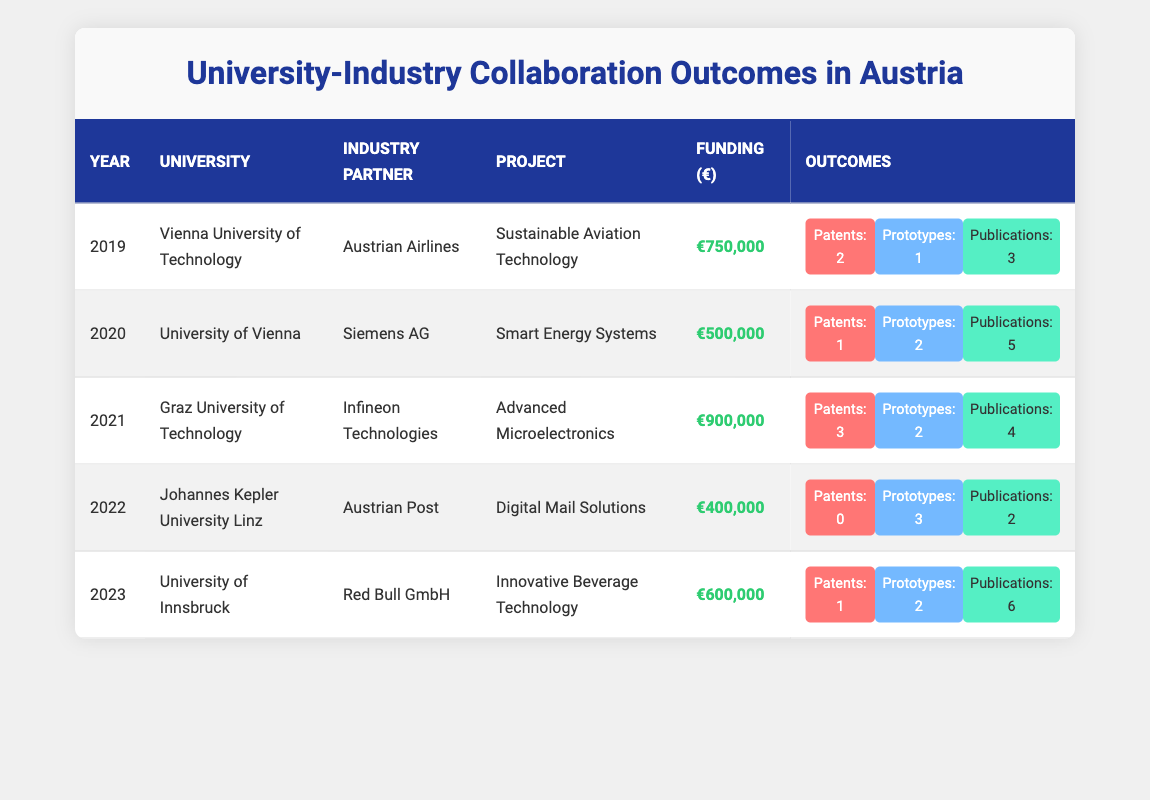What was the funding amount for the project "Sustainable Aviation Technology"? The funding amount for the project "Sustainable Aviation Technology" is displayed in the row for the year 2019, which shows a funding of €750,000.
Answer: €750,000 Which university collaborated with Red Bull GmbH in 2023? According to the table, the university that collaborated with Red Bull GmbH in 2023 is the University of Innsbruck, as seen in the row for that year.
Answer: University of Innsbruck What is the total number of patents produced from collaborations in 2020 and 2021? To find the total patents produced, we look at the values in the outcomes for those years. In 2020, there was 1 patent and in 2021, there were 3 patents. So, we sum these up: 1 + 3 = 4.
Answer: 4 Did Johannes Kepler University Linz produce any patents in 2022? Looking at the row for 2022, it shows that Johannes Kepler University Linz produced 0 patents for the project "Digital Mail Solutions".
Answer: No Which collaboration had the highest funding amount and what was that amount? To determine which collaboration had the highest funding, we examine the funding amounts from each row. The row for Graz University of Technology in 2021 shows the highest funding of €900,000 for the project "Advanced Microelectronics".
Answer: €900,000 What was the average number of prototypes across all projects from 2019 to 2023? We list the prototypes produced for each year: 1 in 2019, 2 in 2020, 2 in 2021, 3 in 2022, and 2 in 2023. The total prototypes are 1 + 2 + 2 + 3 + 2 = 10. There are 5 projects, so the average is 10 / 5 = 2.
Answer: 2 Which industry partner had collaborations with two different universities and what were the projects? Looking through the table, both Siemens AG (2020) with the project "Smart Energy Systems" and Red Bull GmbH (2023) with the project "Innovative Beverage Technology" have unique collaborations. However, the only industry partner that seems to have one is Red Bull GmbH. Hence, the question relates to narrowing it down as none had dual collaboration with a project here.
Answer: None (there's no industry partner with collaborations from two universities) In how many years were patents produced according to the table? By checking each row for patents, we see that patents were produced in 2019 (2), 2020 (1), 2021 (3), and 2023 (1). The only year without patents is 2022. Thus, patents were produced in 4 different years.
Answer: 4 